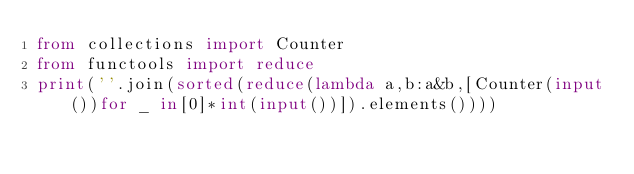<code> <loc_0><loc_0><loc_500><loc_500><_Python_>from collections import Counter
from functools import reduce
print(''.join(sorted(reduce(lambda a,b:a&b,[Counter(input())for _ in[0]*int(input())]).elements())))</code> 